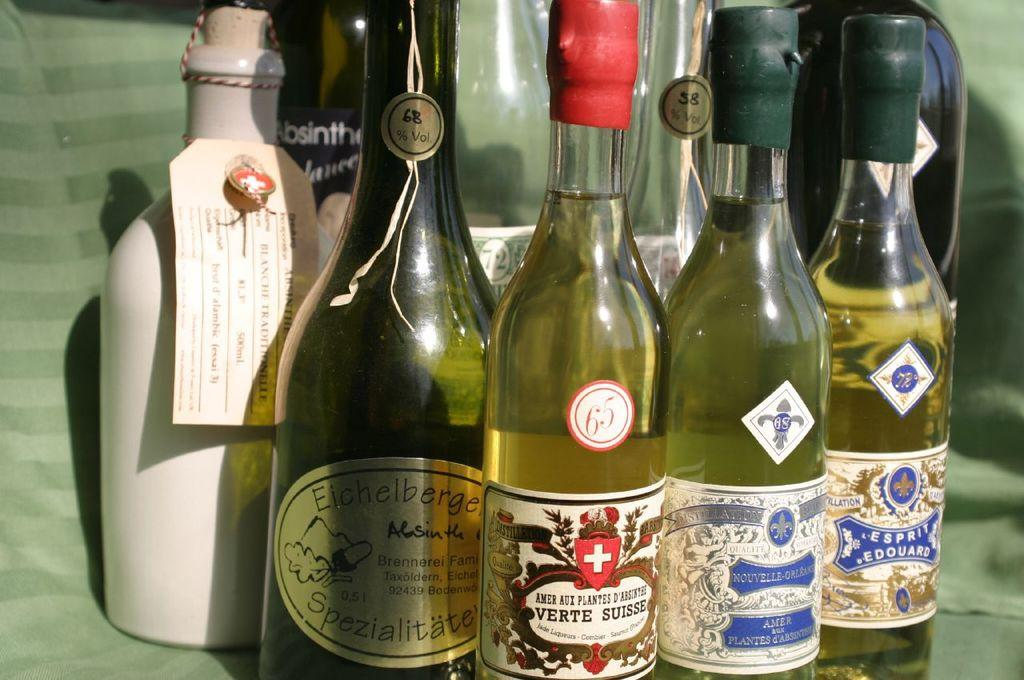<image>
Write a terse but informative summary of the picture. A bottle of Verte Suisse is with several other bottles. 